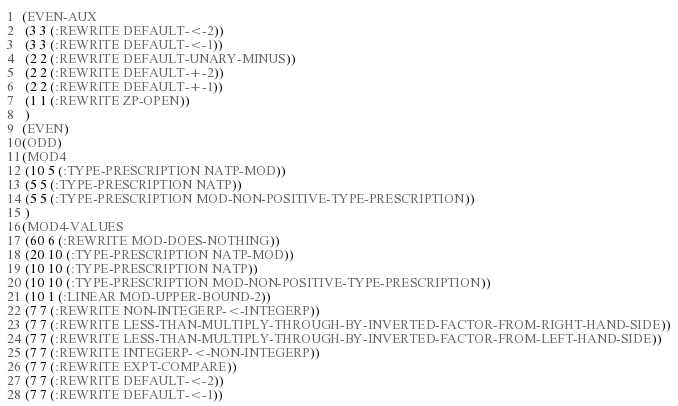<code> <loc_0><loc_0><loc_500><loc_500><_Lisp_>(EVEN-AUX
 (3 3 (:REWRITE DEFAULT-<-2))
 (3 3 (:REWRITE DEFAULT-<-1))
 (2 2 (:REWRITE DEFAULT-UNARY-MINUS))
 (2 2 (:REWRITE DEFAULT-+-2))
 (2 2 (:REWRITE DEFAULT-+-1))
 (1 1 (:REWRITE ZP-OPEN))
 )
(EVEN)
(ODD)
(MOD4
 (10 5 (:TYPE-PRESCRIPTION NATP-MOD))
 (5 5 (:TYPE-PRESCRIPTION NATP))
 (5 5 (:TYPE-PRESCRIPTION MOD-NON-POSITIVE-TYPE-PRESCRIPTION))
 )
(MOD4-VALUES
 (60 6 (:REWRITE MOD-DOES-NOTHING))
 (20 10 (:TYPE-PRESCRIPTION NATP-MOD))
 (10 10 (:TYPE-PRESCRIPTION NATP))
 (10 10 (:TYPE-PRESCRIPTION MOD-NON-POSITIVE-TYPE-PRESCRIPTION))
 (10 1 (:LINEAR MOD-UPPER-BOUND-2))
 (7 7 (:REWRITE NON-INTEGERP-<-INTEGERP))
 (7 7 (:REWRITE LESS-THAN-MULTIPLY-THROUGH-BY-INVERTED-FACTOR-FROM-RIGHT-HAND-SIDE))
 (7 7 (:REWRITE LESS-THAN-MULTIPLY-THROUGH-BY-INVERTED-FACTOR-FROM-LEFT-HAND-SIDE))
 (7 7 (:REWRITE INTEGERP-<-NON-INTEGERP))
 (7 7 (:REWRITE EXPT-COMPARE))
 (7 7 (:REWRITE DEFAULT-<-2))
 (7 7 (:REWRITE DEFAULT-<-1))</code> 